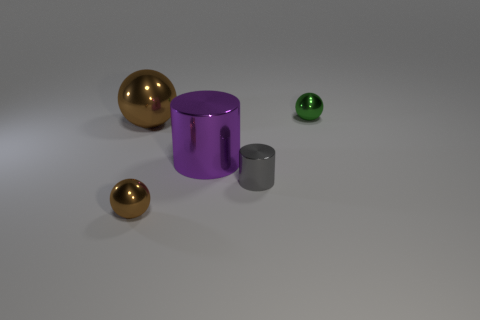Add 2 big purple cylinders. How many objects exist? 7 Subtract all brown spheres. How many spheres are left? 1 Subtract all purple cylinders. How many brown spheres are left? 2 Subtract all gray cylinders. How many cylinders are left? 1 Subtract all balls. How many objects are left? 2 Subtract all gray cylinders. Subtract all red blocks. How many cylinders are left? 1 Subtract all brown shiny things. Subtract all blue matte objects. How many objects are left? 3 Add 2 metal cylinders. How many metal cylinders are left? 4 Add 3 purple metal cylinders. How many purple metal cylinders exist? 4 Subtract 0 gray balls. How many objects are left? 5 